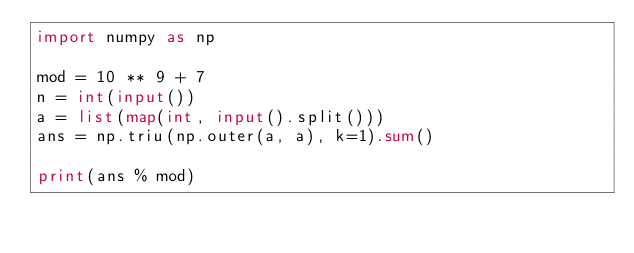Convert code to text. <code><loc_0><loc_0><loc_500><loc_500><_Python_>import numpy as np

mod = 10 ** 9 + 7
n = int(input())
a = list(map(int, input().split()))
ans = np.triu(np.outer(a, a), k=1).sum()

print(ans % mod)
</code> 